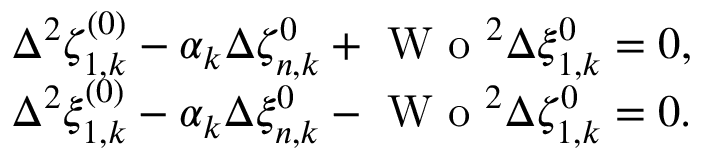<formula> <loc_0><loc_0><loc_500><loc_500>\begin{array} { r l } & { \Delta ^ { 2 } \zeta _ { 1 , k } ^ { ( 0 ) } - \alpha _ { k } \Delta \zeta _ { n , k } ^ { 0 } + W o ^ { 2 } \Delta \xi _ { 1 , k } ^ { 0 } = 0 , } \\ & { \Delta ^ { 2 } \xi _ { 1 , k } ^ { ( 0 ) } - \alpha _ { k } \Delta \xi _ { n , k } ^ { 0 } - W o ^ { 2 } \Delta \zeta _ { 1 , k } ^ { 0 } = 0 . } \end{array}</formula> 